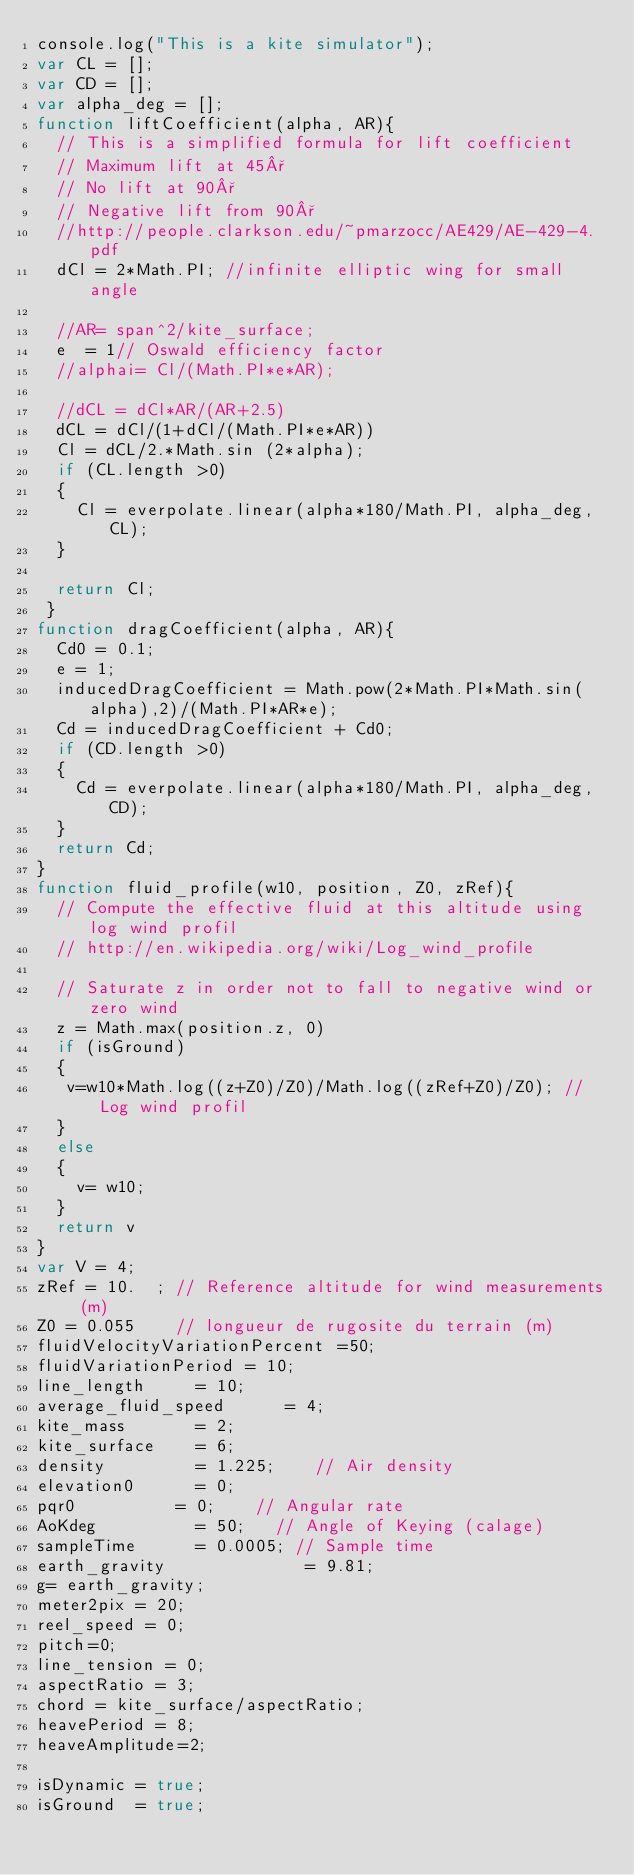<code> <loc_0><loc_0><loc_500><loc_500><_JavaScript_>console.log("This is a kite simulator");
var CL = [];
var CD = [];
var alpha_deg = [];
function liftCoefficient(alpha, AR){
  // This is a simplified formula for lift coefficient
  // Maximum lift at 45°
  // No lift at 90°
  // Negative lift from 90°
  //http://people.clarkson.edu/~pmarzocc/AE429/AE-429-4.pdf
  dCl = 2*Math.PI; //infinite elliptic wing for small angle
  
  //AR= span^2/kite_surface;
  e  = 1// Oswald efficiency factor
  //alphai= Cl/(Math.PI*e*AR);
  
  //dCL = dCl*AR/(AR+2.5)
  dCL = dCl/(1+dCl/(Math.PI*e*AR))
  Cl = dCL/2.*Math.sin (2*alpha);
  if (CL.length >0)
  {
    Cl = everpolate.linear(alpha*180/Math.PI, alpha_deg, CL);
  }

  return Cl;
 }
function dragCoefficient(alpha, AR){
  Cd0 = 0.1;
  e = 1;
  inducedDragCoefficient = Math.pow(2*Math.PI*Math.sin(alpha),2)/(Math.PI*AR*e);
  Cd = inducedDragCoefficient + Cd0;
  if (CD.length >0)
  {
    Cd = everpolate.linear(alpha*180/Math.PI, alpha_deg, CD);
  }
  return Cd;
}
function fluid_profile(w10, position, Z0, zRef){
  // Compute the effective fluid at this altitude using log wind profil
  // http://en.wikipedia.org/wiki/Log_wind_profile
  
  // Saturate z in order not to fall to negative wind or zero wind
  z = Math.max(position.z, 0)
  if (isGround)
  {
   v=w10*Math.log((z+Z0)/Z0)/Math.log((zRef+Z0)/Z0); //Log wind profil 
  }
  else
  {
    v= w10;
  }
  return v
}
var V = 4;
zRef = 10.  ; // Reference altitude for wind measurements (m)
Z0 = 0.055    // longueur de rugosite du terrain (m)
fluidVelocityVariationPercent =50;
fluidVariationPeriod = 10;
line_length     = 10;
average_fluid_speed      = 4;
kite_mass       = 2;  
kite_surface    = 6;  
density         = 1.225;    // Air density
elevation0      = 0;
pqr0          = 0;    // Angular rate
AoKdeg          = 50;   // Angle of Keying (calage)
sampleTime      = 0.0005; // Sample time
earth_gravity              = 9.81;
g= earth_gravity;
meter2pix = 20;
reel_speed = 0;
pitch=0;
line_tension = 0;
aspectRatio = 3;
chord = kite_surface/aspectRatio;
heavePeriod = 8;
heaveAmplitude=2;

isDynamic = true;
isGround  = true;
</code> 